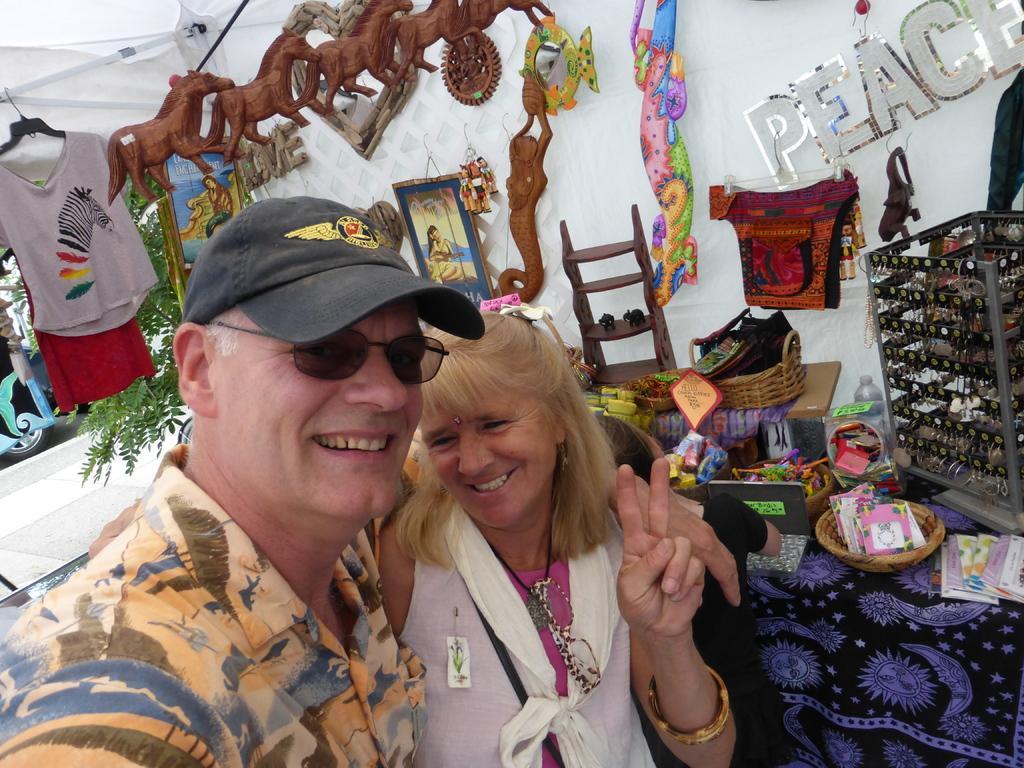How would you summarize this image in a sentence or two? In this image we can see a two persons are standing, and smiling, he is wearing the orange color shirt, here are the toys, here is the tree, here are some objects. 